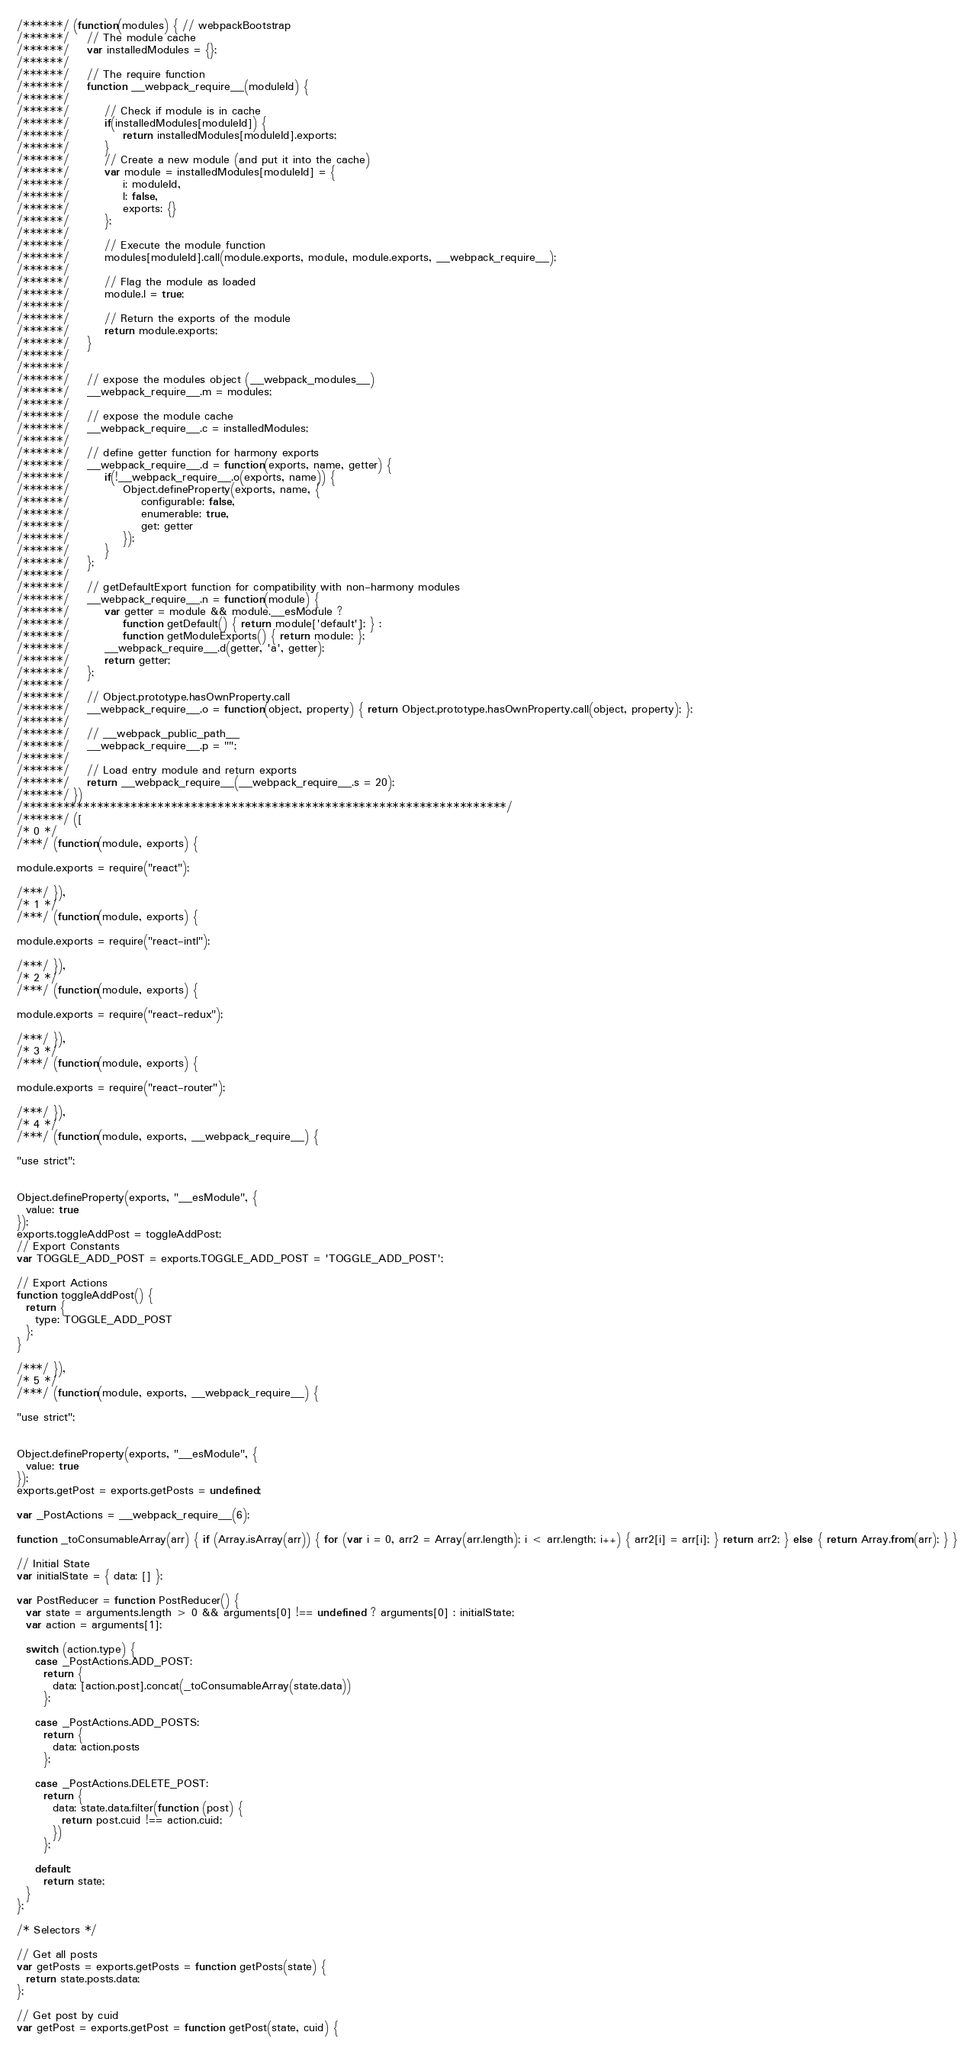Convert code to text. <code><loc_0><loc_0><loc_500><loc_500><_JavaScript_>/******/ (function(modules) { // webpackBootstrap
/******/ 	// The module cache
/******/ 	var installedModules = {};
/******/
/******/ 	// The require function
/******/ 	function __webpack_require__(moduleId) {
/******/
/******/ 		// Check if module is in cache
/******/ 		if(installedModules[moduleId]) {
/******/ 			return installedModules[moduleId].exports;
/******/ 		}
/******/ 		// Create a new module (and put it into the cache)
/******/ 		var module = installedModules[moduleId] = {
/******/ 			i: moduleId,
/******/ 			l: false,
/******/ 			exports: {}
/******/ 		};
/******/
/******/ 		// Execute the module function
/******/ 		modules[moduleId].call(module.exports, module, module.exports, __webpack_require__);
/******/
/******/ 		// Flag the module as loaded
/******/ 		module.l = true;
/******/
/******/ 		// Return the exports of the module
/******/ 		return module.exports;
/******/ 	}
/******/
/******/
/******/ 	// expose the modules object (__webpack_modules__)
/******/ 	__webpack_require__.m = modules;
/******/
/******/ 	// expose the module cache
/******/ 	__webpack_require__.c = installedModules;
/******/
/******/ 	// define getter function for harmony exports
/******/ 	__webpack_require__.d = function(exports, name, getter) {
/******/ 		if(!__webpack_require__.o(exports, name)) {
/******/ 			Object.defineProperty(exports, name, {
/******/ 				configurable: false,
/******/ 				enumerable: true,
/******/ 				get: getter
/******/ 			});
/******/ 		}
/******/ 	};
/******/
/******/ 	// getDefaultExport function for compatibility with non-harmony modules
/******/ 	__webpack_require__.n = function(module) {
/******/ 		var getter = module && module.__esModule ?
/******/ 			function getDefault() { return module['default']; } :
/******/ 			function getModuleExports() { return module; };
/******/ 		__webpack_require__.d(getter, 'a', getter);
/******/ 		return getter;
/******/ 	};
/******/
/******/ 	// Object.prototype.hasOwnProperty.call
/******/ 	__webpack_require__.o = function(object, property) { return Object.prototype.hasOwnProperty.call(object, property); };
/******/
/******/ 	// __webpack_public_path__
/******/ 	__webpack_require__.p = "";
/******/
/******/ 	// Load entry module and return exports
/******/ 	return __webpack_require__(__webpack_require__.s = 20);
/******/ })
/************************************************************************/
/******/ ([
/* 0 */
/***/ (function(module, exports) {

module.exports = require("react");

/***/ }),
/* 1 */
/***/ (function(module, exports) {

module.exports = require("react-intl");

/***/ }),
/* 2 */
/***/ (function(module, exports) {

module.exports = require("react-redux");

/***/ }),
/* 3 */
/***/ (function(module, exports) {

module.exports = require("react-router");

/***/ }),
/* 4 */
/***/ (function(module, exports, __webpack_require__) {

"use strict";


Object.defineProperty(exports, "__esModule", {
  value: true
});
exports.toggleAddPost = toggleAddPost;
// Export Constants
var TOGGLE_ADD_POST = exports.TOGGLE_ADD_POST = 'TOGGLE_ADD_POST';

// Export Actions
function toggleAddPost() {
  return {
    type: TOGGLE_ADD_POST
  };
}

/***/ }),
/* 5 */
/***/ (function(module, exports, __webpack_require__) {

"use strict";


Object.defineProperty(exports, "__esModule", {
  value: true
});
exports.getPost = exports.getPosts = undefined;

var _PostActions = __webpack_require__(6);

function _toConsumableArray(arr) { if (Array.isArray(arr)) { for (var i = 0, arr2 = Array(arr.length); i < arr.length; i++) { arr2[i] = arr[i]; } return arr2; } else { return Array.from(arr); } }

// Initial State
var initialState = { data: [] };

var PostReducer = function PostReducer() {
  var state = arguments.length > 0 && arguments[0] !== undefined ? arguments[0] : initialState;
  var action = arguments[1];

  switch (action.type) {
    case _PostActions.ADD_POST:
      return {
        data: [action.post].concat(_toConsumableArray(state.data))
      };

    case _PostActions.ADD_POSTS:
      return {
        data: action.posts
      };

    case _PostActions.DELETE_POST:
      return {
        data: state.data.filter(function (post) {
          return post.cuid !== action.cuid;
        })
      };

    default:
      return state;
  }
};

/* Selectors */

// Get all posts
var getPosts = exports.getPosts = function getPosts(state) {
  return state.posts.data;
};

// Get post by cuid
var getPost = exports.getPost = function getPost(state, cuid) {</code> 